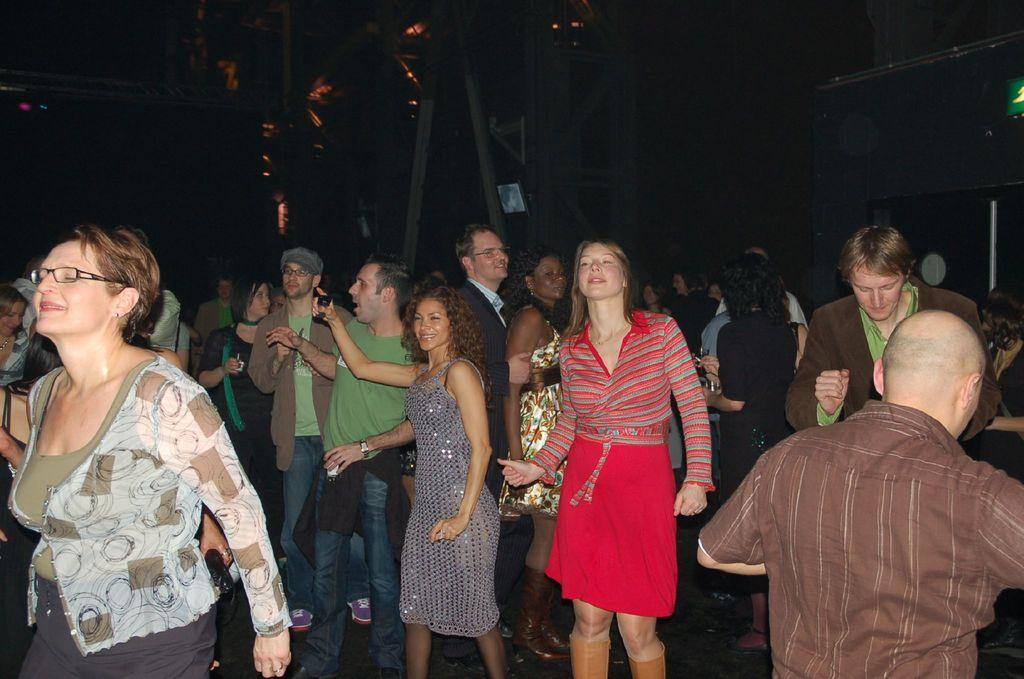What are the people in the image doing? The persons standing on the ground in the image are likely standing or waiting. What objects can be seen in the image besides the people? There are metal rods and lights visible in the image. How would you describe the lighting conditions in the image? The background of the image is dark, which suggests that the lighting is low or dim. How does the digestion of the pigs affect the metal rods in the image? There are no pigs present in the image, so their digestion cannot affect the metal rods. 